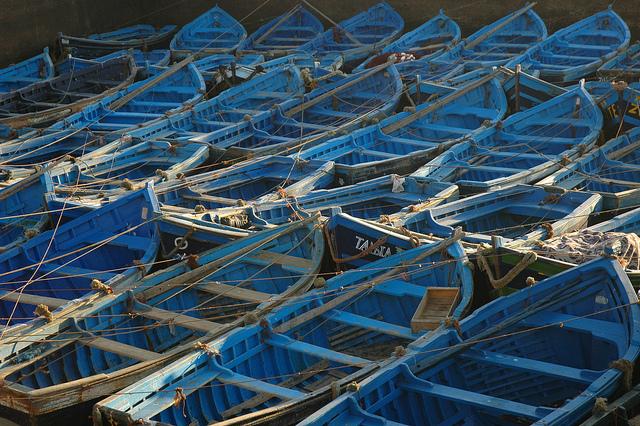Are the boats tied together?
Write a very short answer. Yes. What color are the boats?
Be succinct. Blue. Are these boats in use right now?
Give a very brief answer. No. 